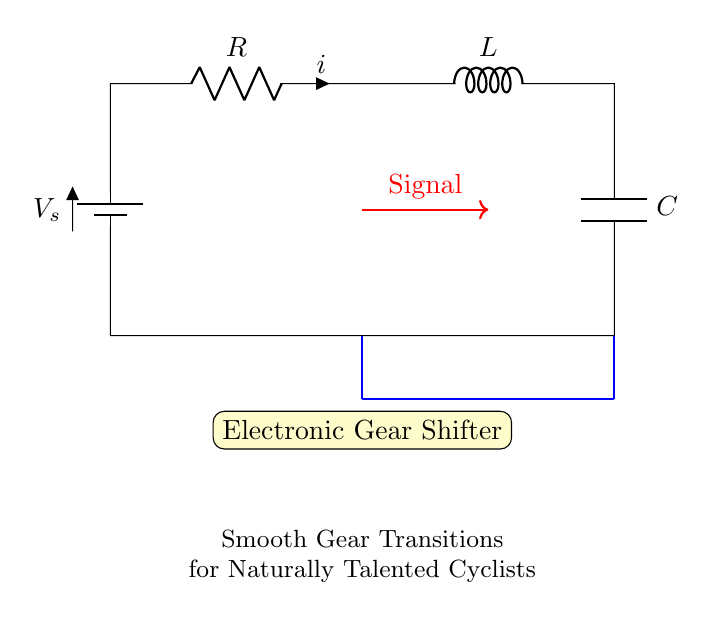What components are in this circuit? The circuit includes a resistor, inductor, and capacitor, which are standard components in an RLC circuit. Each is labeled appropriately in the diagram.
Answer: resistor, inductor, capacitor What is the purpose of the electronic gear shifter? The electronic gear shifter is designed to provide smooth transitions in gear shifting, which is indicated by its placement in the circuit as a key component.
Answer: smooth gear transitions What type of circuit is illustrated here? The circuit type illustrated is an RLC series circuit, as it contains a resistor, inductor, and capacitor connected in series.
Answer: RLC series What signal direction is indicated in the diagram? The signal direction is indicated by the red arrow, pointing from the resistor to the inductor, showing the flow of the electronic signal in the circuit.
Answer: from resistor to inductor How does the inductor affect the transition? The inductor stores energy in a magnetic field and helps to smooth out changes in current, contributing to a gradual gear shift transition.
Answer: smooth current change What role does the capacitor play in the RLC circuit? The capacitor stores electrical energy and releases it when needed, aiding in voltage stabilization and contributing to a smooth gear transition process.
Answer: stores electrical energy What does the battery represent in the circuit? The battery represents the voltage source supplying energy to the circuit, allowing it to function and enabling the components to perform their roles.
Answer: voltage source 